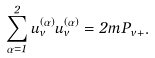Convert formula to latex. <formula><loc_0><loc_0><loc_500><loc_500>\sum _ { \alpha = 1 } ^ { 2 } u ^ { ( \alpha ) } _ { v } \bar { u } ^ { ( \alpha ) } _ { v } = 2 m P _ { v + } .</formula> 